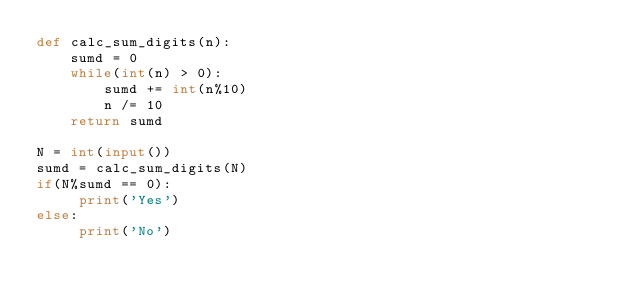Convert code to text. <code><loc_0><loc_0><loc_500><loc_500><_Python_>def calc_sum_digits(n):
    sumd = 0
    while(int(n) > 0):
        sumd += int(n%10)
        n /= 10
    return sumd

N = int(input())
sumd = calc_sum_digits(N)
if(N%sumd == 0):
     print('Yes')
else:
     print('No')</code> 